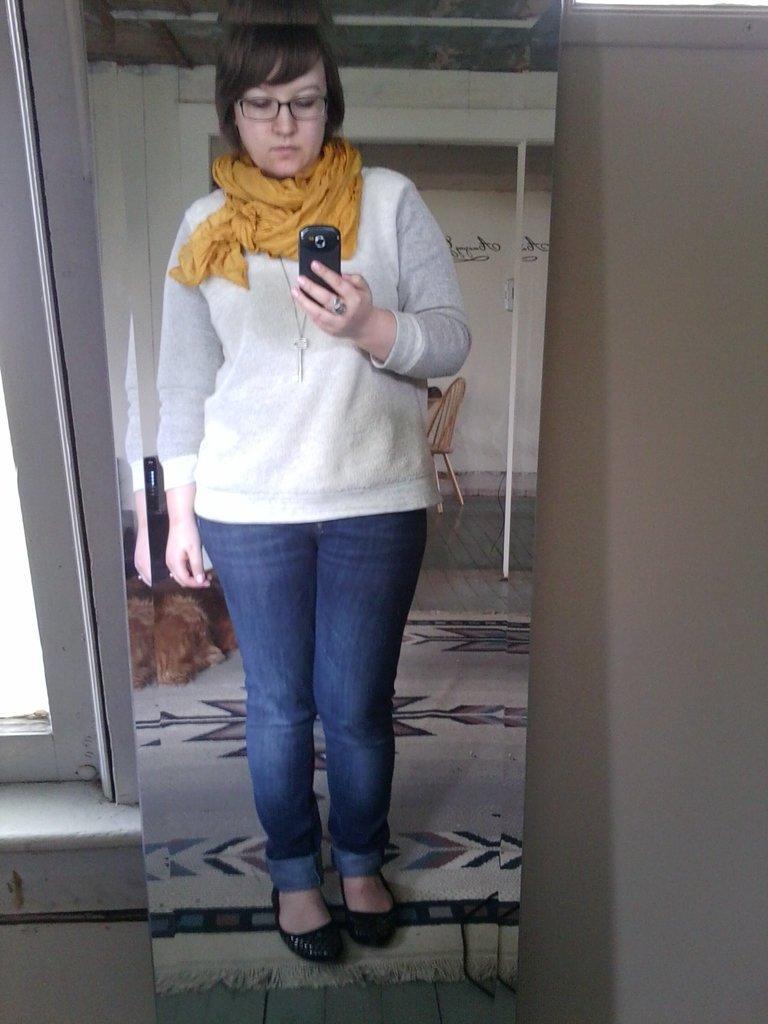Describe this image in one or two sentences. On the mirror we can see the reflection of a woman standing on the floor by holding a mobile in her hand. In the background we can see the wall and window on the left side. 